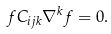Convert formula to latex. <formula><loc_0><loc_0><loc_500><loc_500>f C _ { i j k } \nabla ^ { k } f = 0 .</formula> 